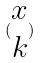<formula> <loc_0><loc_0><loc_500><loc_500>( \begin{matrix} x \\ k \end{matrix} )</formula> 